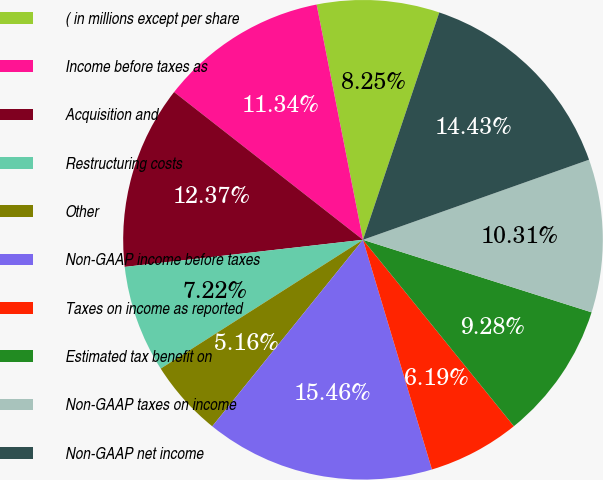Convert chart to OTSL. <chart><loc_0><loc_0><loc_500><loc_500><pie_chart><fcel>( in millions except per share<fcel>Income before taxes as<fcel>Acquisition and<fcel>Restructuring costs<fcel>Other<fcel>Non-GAAP income before taxes<fcel>Taxes on income as reported<fcel>Estimated tax benefit on<fcel>Non-GAAP taxes on income<fcel>Non-GAAP net income<nl><fcel>8.25%<fcel>11.34%<fcel>12.37%<fcel>7.22%<fcel>5.16%<fcel>15.46%<fcel>6.19%<fcel>9.28%<fcel>10.31%<fcel>14.43%<nl></chart> 